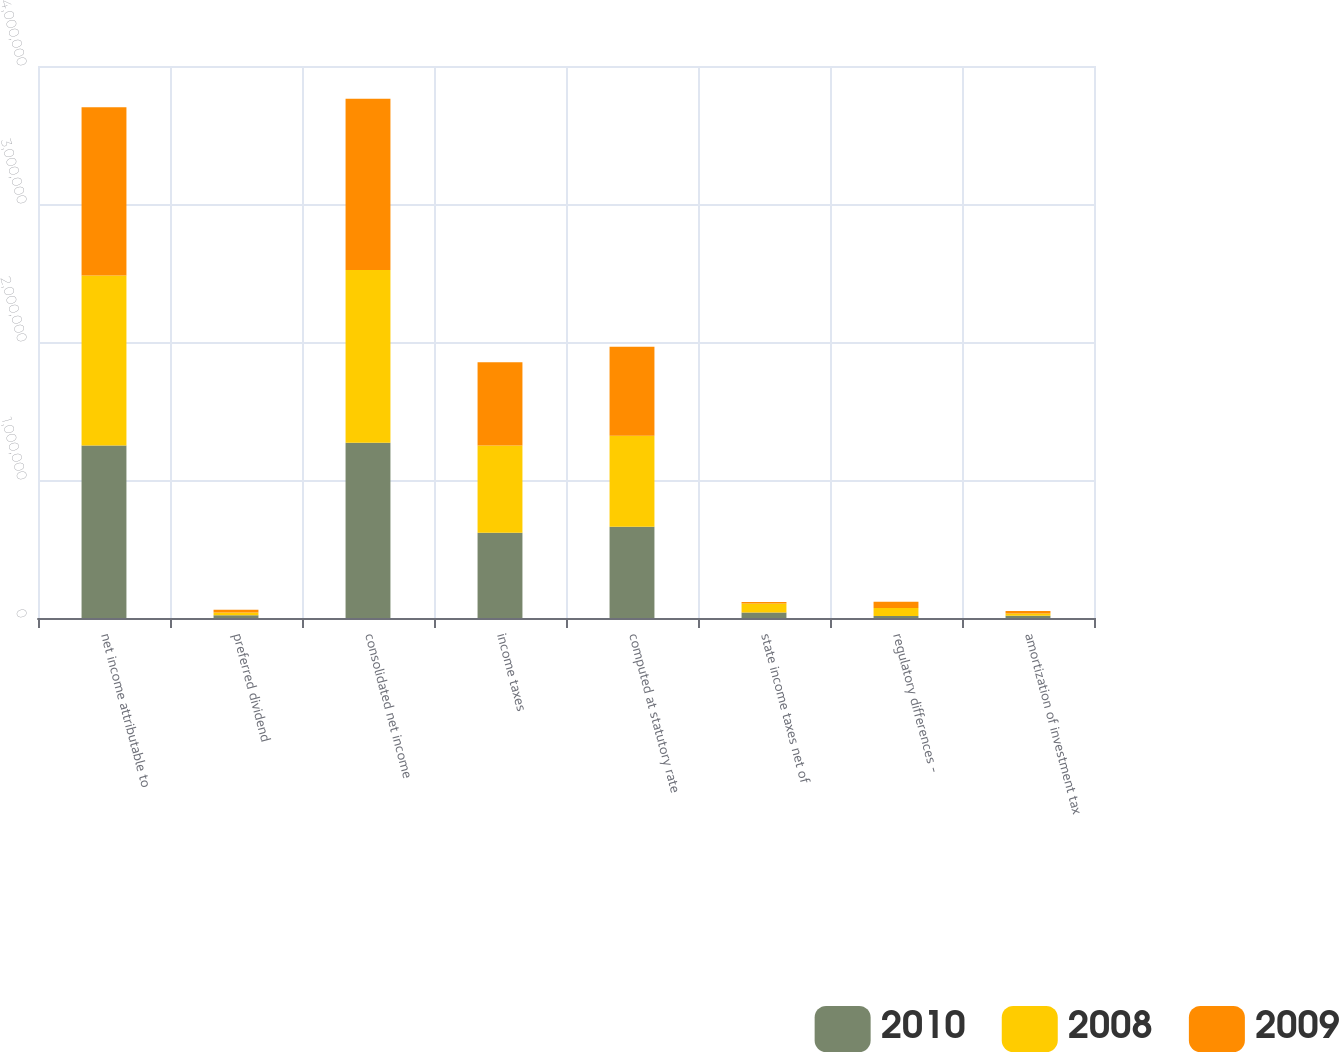Convert chart to OTSL. <chart><loc_0><loc_0><loc_500><loc_500><stacked_bar_chart><ecel><fcel>net income attributable to<fcel>preferred dividend<fcel>consolidated net income<fcel>income taxes<fcel>computed at statutory rate<fcel>state income taxes net of<fcel>regulatory differences -<fcel>amortization of investment tax<nl><fcel>2010<fcel>1.25024e+06<fcel>20063<fcel>1.2703e+06<fcel>617239<fcel>660640<fcel>40530<fcel>14931<fcel>15980<nl><fcel>2008<fcel>1.23109e+06<fcel>19958<fcel>1.25105e+06<fcel>632740<fcel>659327<fcel>65241<fcel>57383<fcel>16745<nl><fcel>2009<fcel>1.22057e+06<fcel>19969<fcel>1.24054e+06<fcel>602998<fcel>645237<fcel>9926<fcel>45543<fcel>17458<nl></chart> 